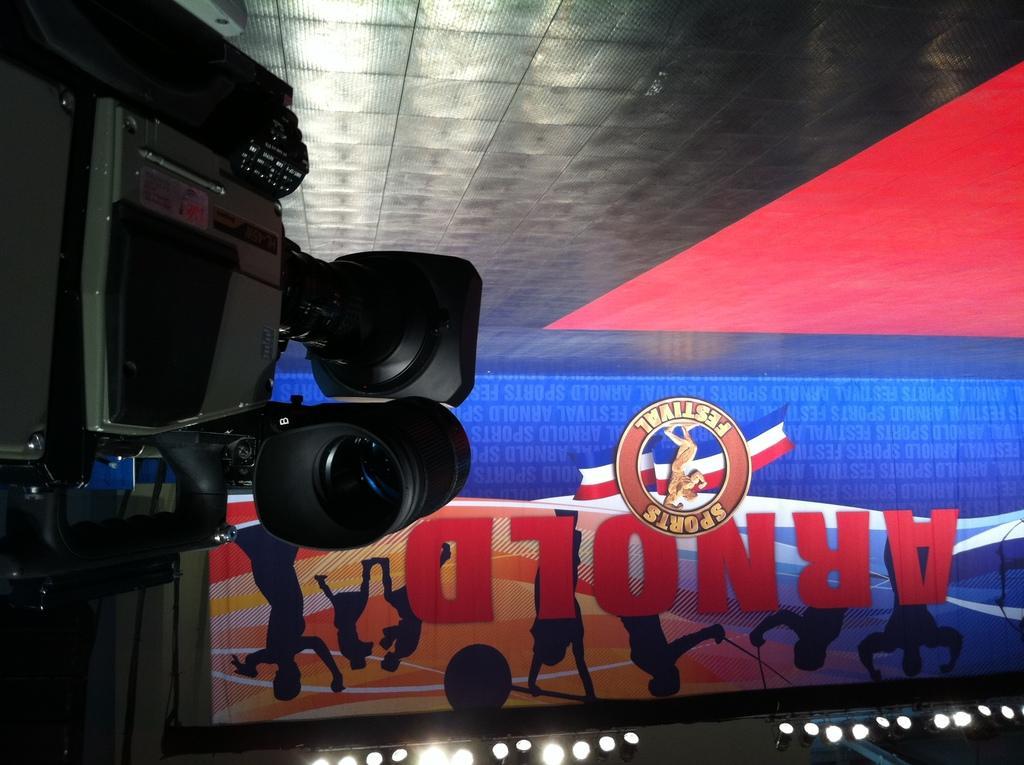Describe this image in one or two sentences. In the image we can see video camera and a poster, on the poster we can see the text. We can even see the lights. 